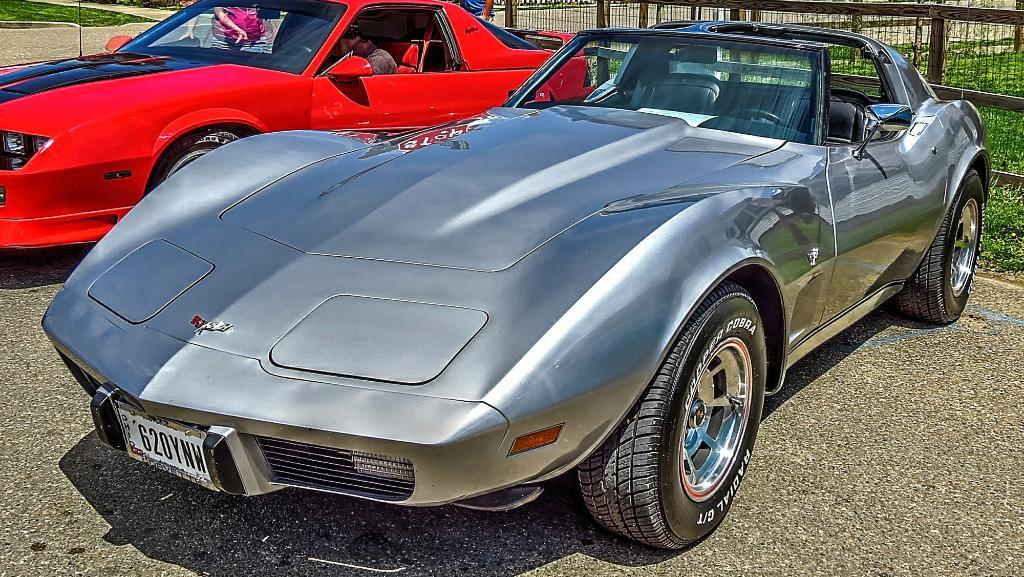How many cars are visible on the road in the image? There are two cars on the road in the image. Can you describe the occupancy of the cars? A person is sitting inside one of the cars. What is happening near the car with the person inside? There are two people standing near the car. What can be seen in the background of the image? There is a fence and plants in the background of the image. Where is the shelf located in the image? There is no shelf present in the image. What type of crib can be seen in the image? There is no crib present in the image. 